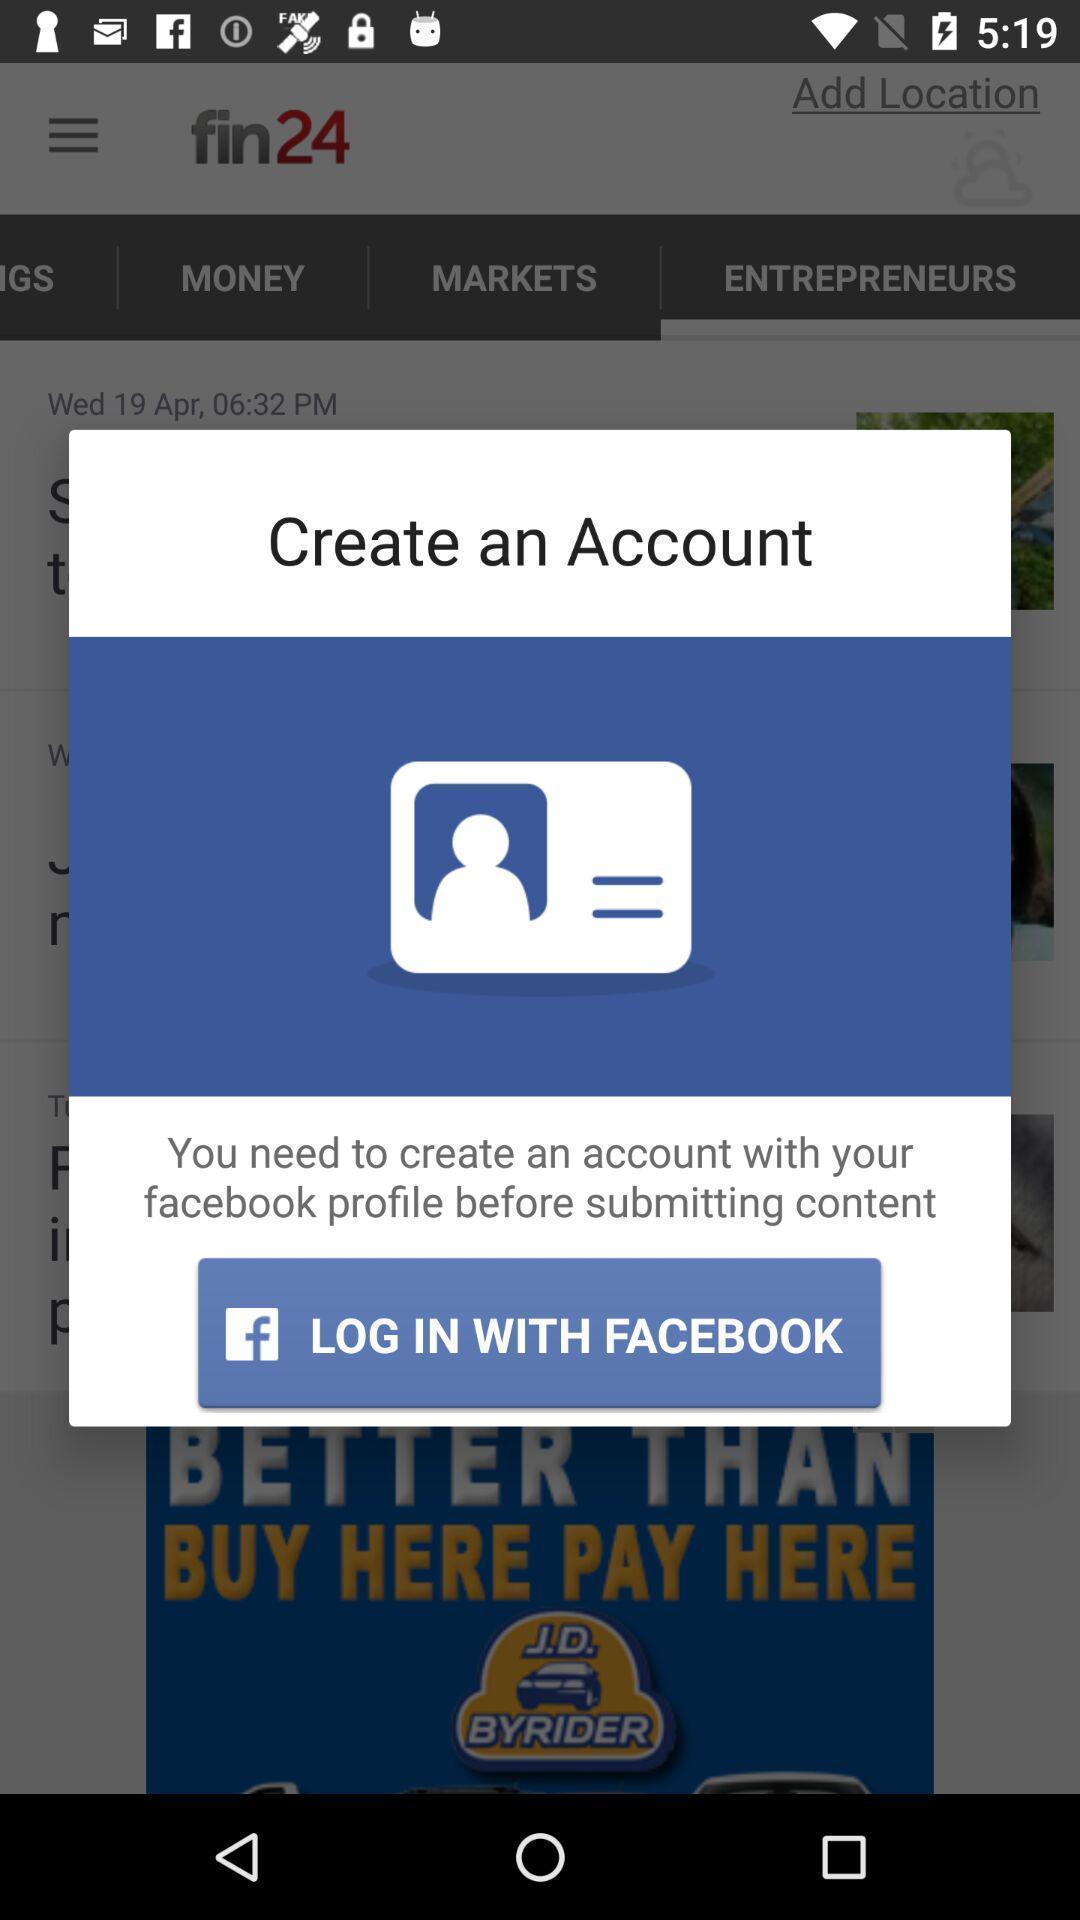Describe this image in words. Pop-up window showing an option to connect account. 